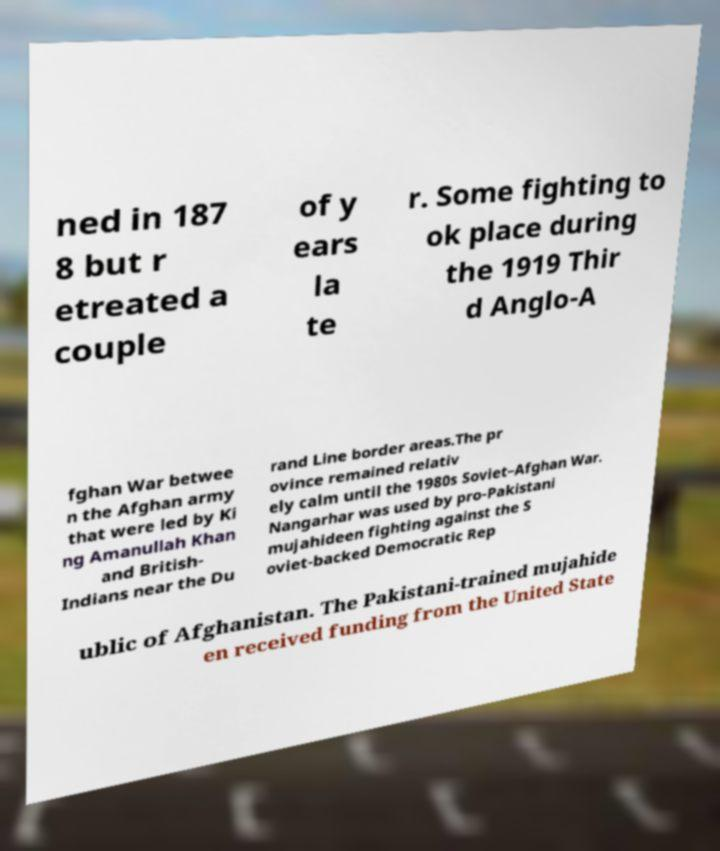Please identify and transcribe the text found in this image. ned in 187 8 but r etreated a couple of y ears la te r. Some fighting to ok place during the 1919 Thir d Anglo-A fghan War betwee n the Afghan army that were led by Ki ng Amanullah Khan and British- Indians near the Du rand Line border areas.The pr ovince remained relativ ely calm until the 1980s Soviet–Afghan War. Nangarhar was used by pro-Pakistani mujahideen fighting against the S oviet-backed Democratic Rep ublic of Afghanistan. The Pakistani-trained mujahide en received funding from the United State 